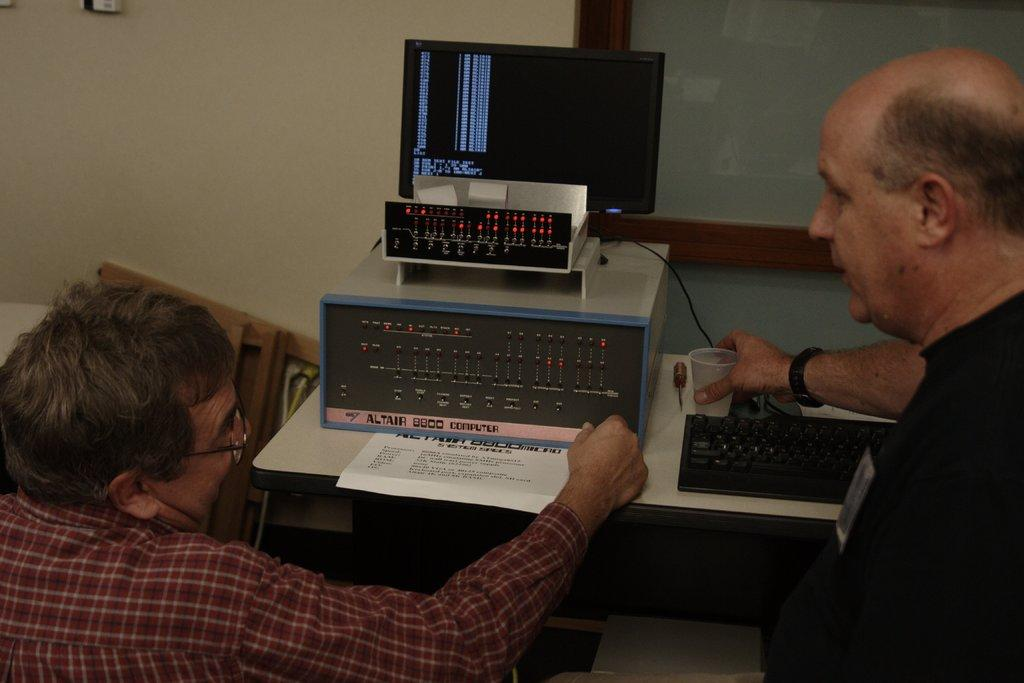<image>
Offer a succinct explanation of the picture presented. Two men are looking and discussing the data from Altair 8800 computer. 